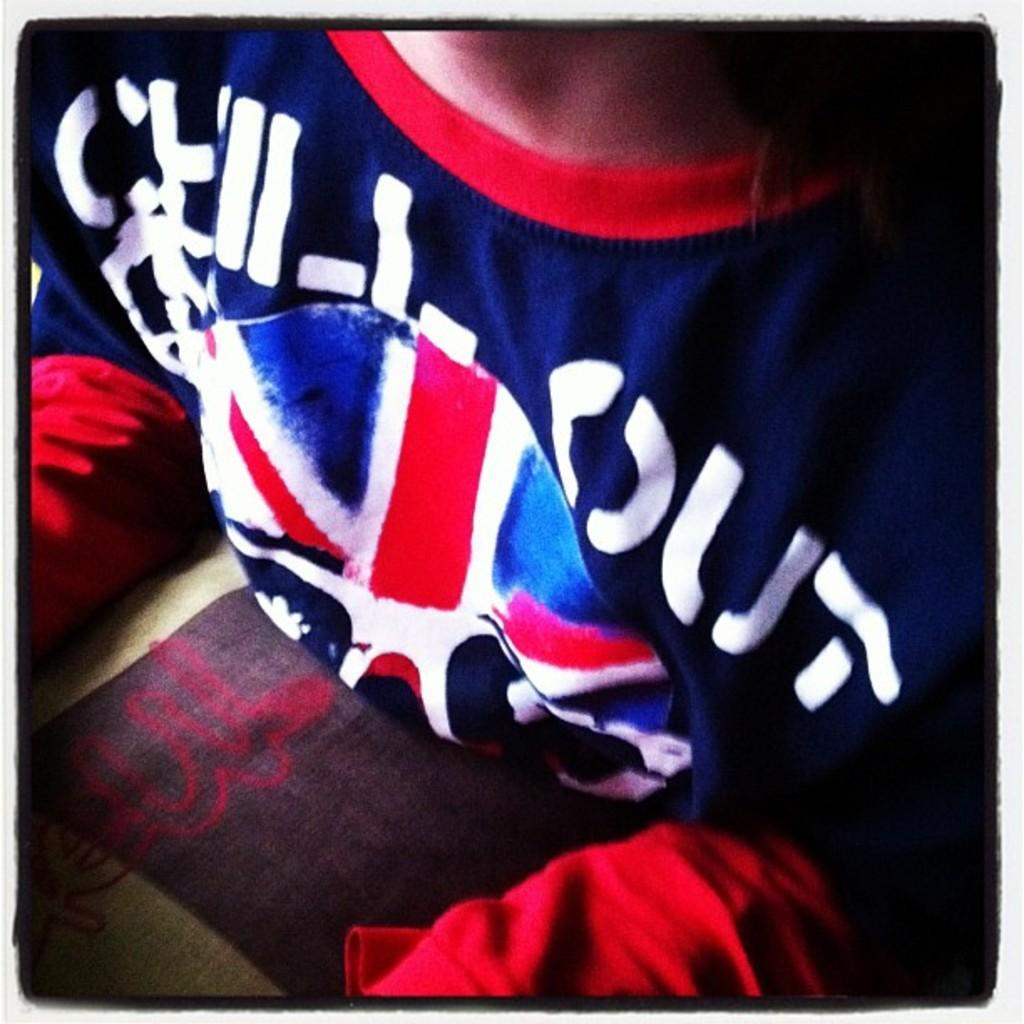Provide a one-sentence caption for the provided image. The only word clearly seen on this jersey is OUT and I cannot tell what is written before it. 